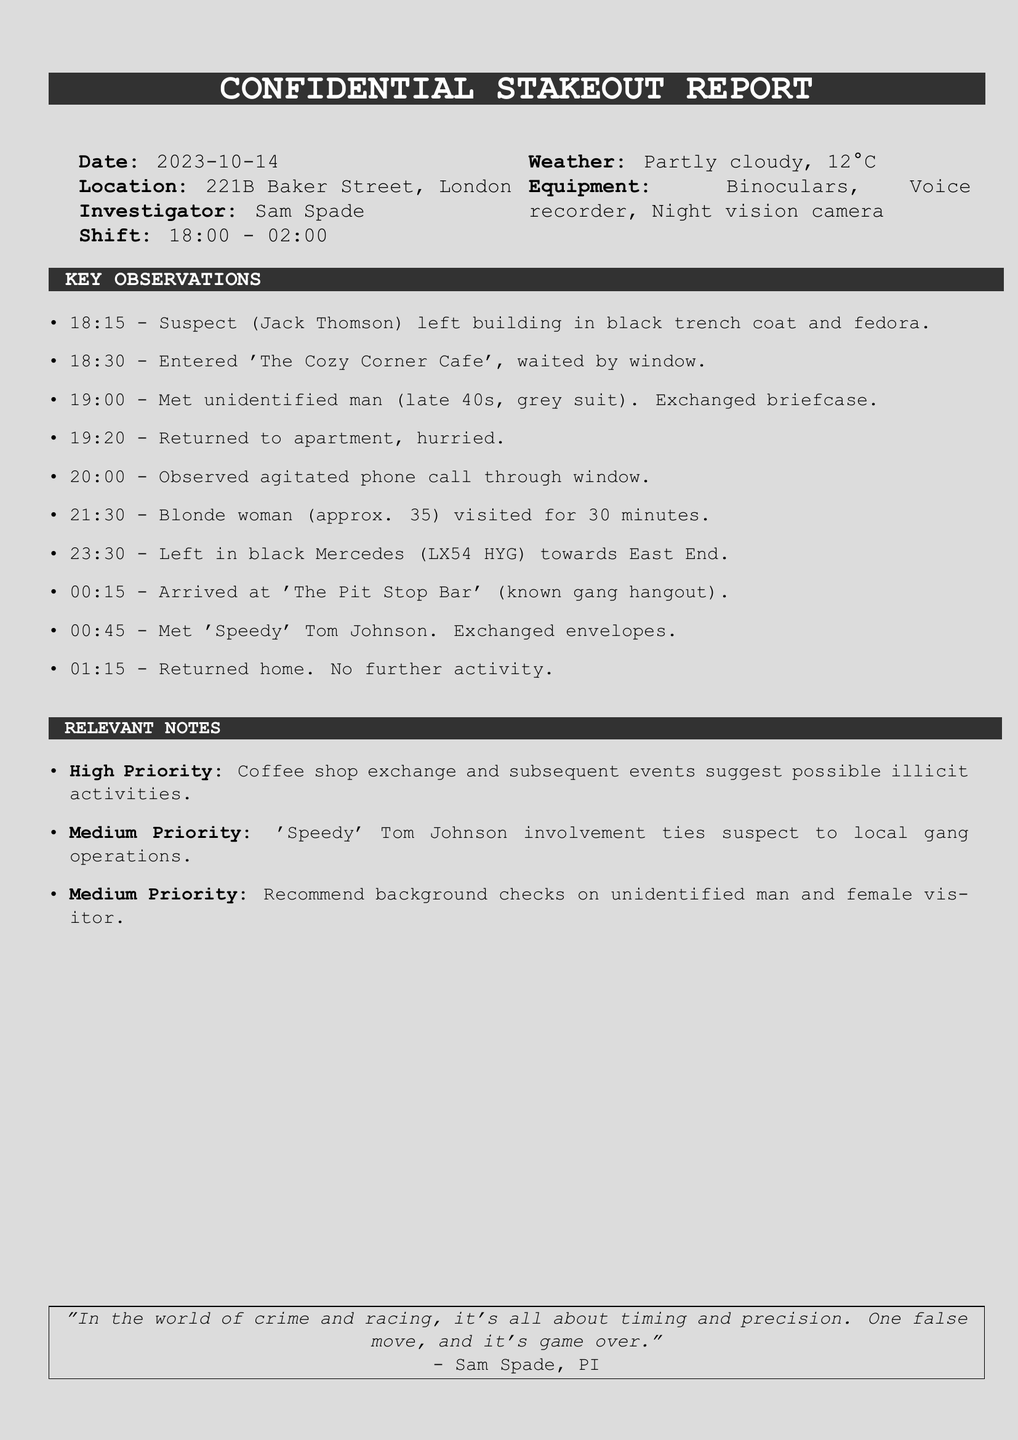What is the date of the stakeout? The date is clearly stated at the beginning of the report.
Answer: 2023-10-14 What was the suspect's name? The name of the suspect is mentioned under the key observations section of the report.
Answer: Jack Thomson What time did the suspect leave the building? The specific time the suspect left is noted in the list of key observations.
Answer: 18:15 What type of vehicle did the suspect take? The description of the vehicle is given when detailing the suspect's movements.
Answer: black Mercedes What activity occurred at 'The Cozy Corner Cafe'? The report details the suspect's meeting with an unidentified man at this location.
Answer: Exchanged briefcase What is noted as a high priority observation? The relevant notes section lists priorities regarding the observations made.
Answer: Coffee shop exchange Who did the suspect meet at 'The Pit Stop Bar'? The report specifies the individual met at this location in the key observations.
Answer: 'Speedy' Tom Johnson What time did the stakeout end? The report indicates when the investigator concluded their shift.
Answer: 02:00 How long did the blonde woman visit the suspect? The duration of the visit is noted in the key observations section.
Answer: 30 minutes 